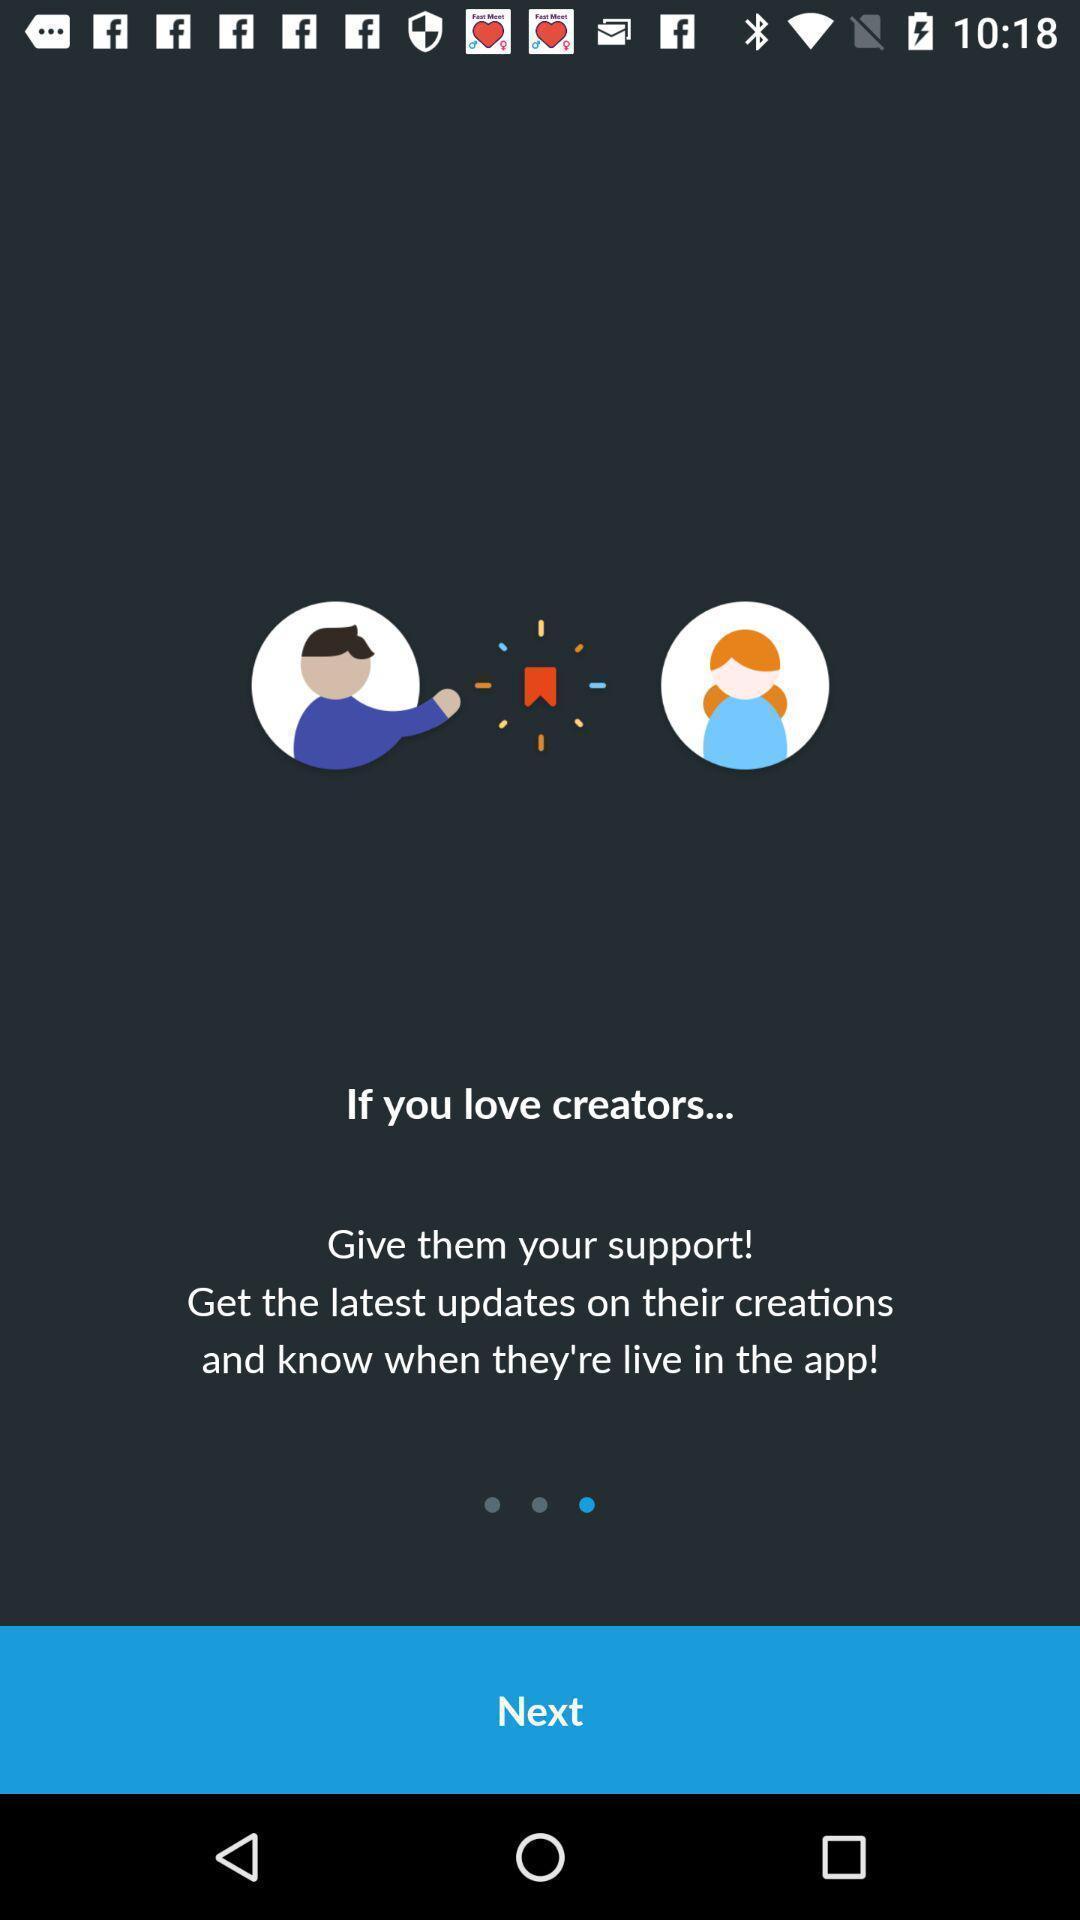Give me a narrative description of this picture. Welcome page of dating app. 